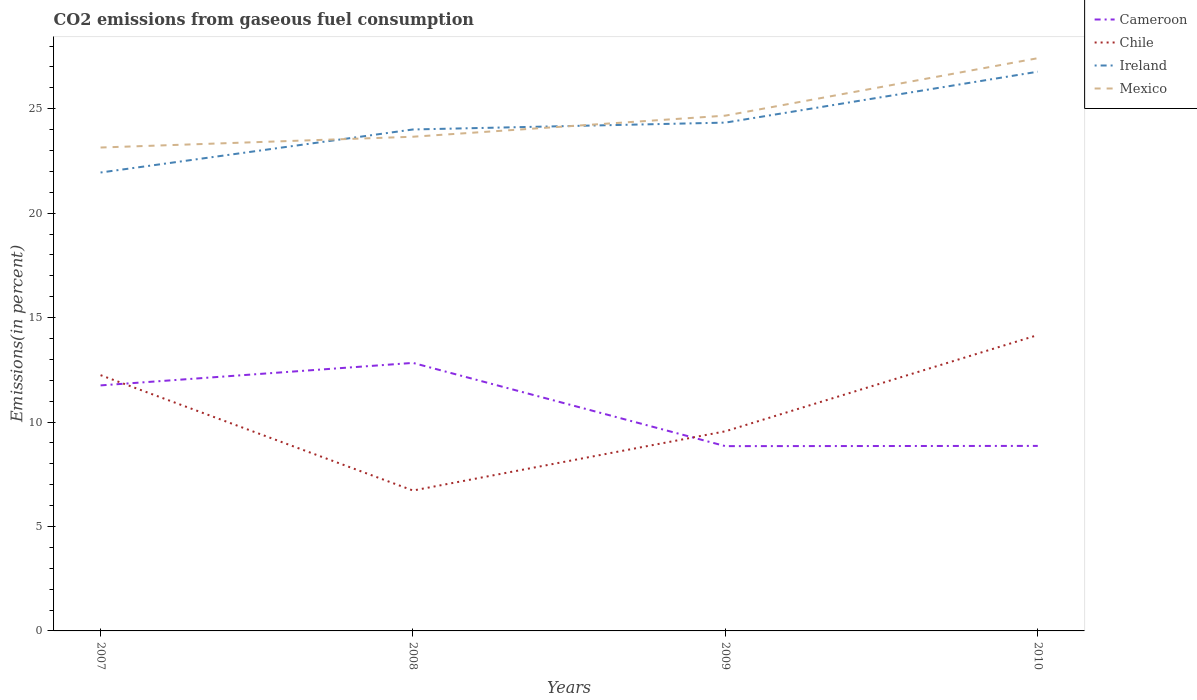How many different coloured lines are there?
Give a very brief answer. 4. Does the line corresponding to Ireland intersect with the line corresponding to Cameroon?
Provide a succinct answer. No. Is the number of lines equal to the number of legend labels?
Your response must be concise. Yes. Across all years, what is the maximum total CO2 emitted in Ireland?
Give a very brief answer. 21.95. What is the total total CO2 emitted in Ireland in the graph?
Your answer should be very brief. -4.83. What is the difference between the highest and the second highest total CO2 emitted in Chile?
Offer a terse response. 7.44. What is the difference between the highest and the lowest total CO2 emitted in Mexico?
Your answer should be very brief. 1. Is the total CO2 emitted in Chile strictly greater than the total CO2 emitted in Cameroon over the years?
Provide a short and direct response. No. How many years are there in the graph?
Provide a succinct answer. 4. Are the values on the major ticks of Y-axis written in scientific E-notation?
Ensure brevity in your answer.  No. Does the graph contain any zero values?
Ensure brevity in your answer.  No. How many legend labels are there?
Your answer should be very brief. 4. What is the title of the graph?
Give a very brief answer. CO2 emissions from gaseous fuel consumption. What is the label or title of the X-axis?
Give a very brief answer. Years. What is the label or title of the Y-axis?
Make the answer very short. Emissions(in percent). What is the Emissions(in percent) in Cameroon in 2007?
Provide a short and direct response. 11.75. What is the Emissions(in percent) in Chile in 2007?
Make the answer very short. 12.24. What is the Emissions(in percent) of Ireland in 2007?
Your response must be concise. 21.95. What is the Emissions(in percent) of Mexico in 2007?
Provide a succinct answer. 23.14. What is the Emissions(in percent) in Cameroon in 2008?
Make the answer very short. 12.83. What is the Emissions(in percent) in Chile in 2008?
Keep it short and to the point. 6.72. What is the Emissions(in percent) of Ireland in 2008?
Offer a terse response. 24.01. What is the Emissions(in percent) in Mexico in 2008?
Your answer should be compact. 23.66. What is the Emissions(in percent) of Cameroon in 2009?
Offer a very short reply. 8.85. What is the Emissions(in percent) in Chile in 2009?
Make the answer very short. 9.56. What is the Emissions(in percent) in Ireland in 2009?
Give a very brief answer. 24.33. What is the Emissions(in percent) in Mexico in 2009?
Provide a short and direct response. 24.67. What is the Emissions(in percent) of Cameroon in 2010?
Make the answer very short. 8.86. What is the Emissions(in percent) in Chile in 2010?
Offer a terse response. 14.16. What is the Emissions(in percent) of Ireland in 2010?
Your response must be concise. 26.77. What is the Emissions(in percent) of Mexico in 2010?
Keep it short and to the point. 27.42. Across all years, what is the maximum Emissions(in percent) of Cameroon?
Your response must be concise. 12.83. Across all years, what is the maximum Emissions(in percent) of Chile?
Provide a succinct answer. 14.16. Across all years, what is the maximum Emissions(in percent) of Ireland?
Keep it short and to the point. 26.77. Across all years, what is the maximum Emissions(in percent) of Mexico?
Give a very brief answer. 27.42. Across all years, what is the minimum Emissions(in percent) in Cameroon?
Your answer should be very brief. 8.85. Across all years, what is the minimum Emissions(in percent) of Chile?
Keep it short and to the point. 6.72. Across all years, what is the minimum Emissions(in percent) of Ireland?
Your answer should be very brief. 21.95. Across all years, what is the minimum Emissions(in percent) of Mexico?
Provide a succinct answer. 23.14. What is the total Emissions(in percent) of Cameroon in the graph?
Provide a succinct answer. 42.29. What is the total Emissions(in percent) of Chile in the graph?
Provide a short and direct response. 42.69. What is the total Emissions(in percent) in Ireland in the graph?
Your answer should be very brief. 97.06. What is the total Emissions(in percent) of Mexico in the graph?
Give a very brief answer. 98.88. What is the difference between the Emissions(in percent) in Cameroon in 2007 and that in 2008?
Give a very brief answer. -1.08. What is the difference between the Emissions(in percent) in Chile in 2007 and that in 2008?
Your response must be concise. 5.52. What is the difference between the Emissions(in percent) in Ireland in 2007 and that in 2008?
Keep it short and to the point. -2.06. What is the difference between the Emissions(in percent) in Mexico in 2007 and that in 2008?
Your answer should be compact. -0.52. What is the difference between the Emissions(in percent) in Cameroon in 2007 and that in 2009?
Provide a short and direct response. 2.91. What is the difference between the Emissions(in percent) in Chile in 2007 and that in 2009?
Provide a short and direct response. 2.69. What is the difference between the Emissions(in percent) of Ireland in 2007 and that in 2009?
Ensure brevity in your answer.  -2.39. What is the difference between the Emissions(in percent) in Mexico in 2007 and that in 2009?
Ensure brevity in your answer.  -1.53. What is the difference between the Emissions(in percent) in Cameroon in 2007 and that in 2010?
Your response must be concise. 2.9. What is the difference between the Emissions(in percent) in Chile in 2007 and that in 2010?
Ensure brevity in your answer.  -1.92. What is the difference between the Emissions(in percent) of Ireland in 2007 and that in 2010?
Give a very brief answer. -4.83. What is the difference between the Emissions(in percent) of Mexico in 2007 and that in 2010?
Offer a very short reply. -4.28. What is the difference between the Emissions(in percent) of Cameroon in 2008 and that in 2009?
Give a very brief answer. 3.98. What is the difference between the Emissions(in percent) in Chile in 2008 and that in 2009?
Your answer should be compact. -2.83. What is the difference between the Emissions(in percent) in Ireland in 2008 and that in 2009?
Make the answer very short. -0.33. What is the difference between the Emissions(in percent) of Mexico in 2008 and that in 2009?
Make the answer very short. -1.01. What is the difference between the Emissions(in percent) in Cameroon in 2008 and that in 2010?
Make the answer very short. 3.97. What is the difference between the Emissions(in percent) of Chile in 2008 and that in 2010?
Your response must be concise. -7.44. What is the difference between the Emissions(in percent) in Ireland in 2008 and that in 2010?
Provide a short and direct response. -2.77. What is the difference between the Emissions(in percent) in Mexico in 2008 and that in 2010?
Provide a short and direct response. -3.76. What is the difference between the Emissions(in percent) in Cameroon in 2009 and that in 2010?
Offer a terse response. -0.01. What is the difference between the Emissions(in percent) of Chile in 2009 and that in 2010?
Your answer should be compact. -4.61. What is the difference between the Emissions(in percent) in Ireland in 2009 and that in 2010?
Offer a very short reply. -2.44. What is the difference between the Emissions(in percent) of Mexico in 2009 and that in 2010?
Your answer should be very brief. -2.75. What is the difference between the Emissions(in percent) of Cameroon in 2007 and the Emissions(in percent) of Chile in 2008?
Your answer should be very brief. 5.03. What is the difference between the Emissions(in percent) of Cameroon in 2007 and the Emissions(in percent) of Ireland in 2008?
Offer a terse response. -12.25. What is the difference between the Emissions(in percent) of Cameroon in 2007 and the Emissions(in percent) of Mexico in 2008?
Make the answer very short. -11.9. What is the difference between the Emissions(in percent) in Chile in 2007 and the Emissions(in percent) in Ireland in 2008?
Give a very brief answer. -11.76. What is the difference between the Emissions(in percent) in Chile in 2007 and the Emissions(in percent) in Mexico in 2008?
Give a very brief answer. -11.41. What is the difference between the Emissions(in percent) of Ireland in 2007 and the Emissions(in percent) of Mexico in 2008?
Offer a very short reply. -1.71. What is the difference between the Emissions(in percent) in Cameroon in 2007 and the Emissions(in percent) in Chile in 2009?
Your response must be concise. 2.2. What is the difference between the Emissions(in percent) in Cameroon in 2007 and the Emissions(in percent) in Ireland in 2009?
Your answer should be very brief. -12.58. What is the difference between the Emissions(in percent) in Cameroon in 2007 and the Emissions(in percent) in Mexico in 2009?
Offer a terse response. -12.91. What is the difference between the Emissions(in percent) of Chile in 2007 and the Emissions(in percent) of Ireland in 2009?
Ensure brevity in your answer.  -12.09. What is the difference between the Emissions(in percent) in Chile in 2007 and the Emissions(in percent) in Mexico in 2009?
Your answer should be compact. -12.42. What is the difference between the Emissions(in percent) of Ireland in 2007 and the Emissions(in percent) of Mexico in 2009?
Offer a very short reply. -2.72. What is the difference between the Emissions(in percent) in Cameroon in 2007 and the Emissions(in percent) in Chile in 2010?
Provide a short and direct response. -2.41. What is the difference between the Emissions(in percent) of Cameroon in 2007 and the Emissions(in percent) of Ireland in 2010?
Offer a very short reply. -15.02. What is the difference between the Emissions(in percent) in Cameroon in 2007 and the Emissions(in percent) in Mexico in 2010?
Your answer should be very brief. -15.66. What is the difference between the Emissions(in percent) in Chile in 2007 and the Emissions(in percent) in Ireland in 2010?
Keep it short and to the point. -14.53. What is the difference between the Emissions(in percent) in Chile in 2007 and the Emissions(in percent) in Mexico in 2010?
Ensure brevity in your answer.  -15.17. What is the difference between the Emissions(in percent) of Ireland in 2007 and the Emissions(in percent) of Mexico in 2010?
Your answer should be very brief. -5.47. What is the difference between the Emissions(in percent) in Cameroon in 2008 and the Emissions(in percent) in Chile in 2009?
Give a very brief answer. 3.27. What is the difference between the Emissions(in percent) of Cameroon in 2008 and the Emissions(in percent) of Ireland in 2009?
Give a very brief answer. -11.5. What is the difference between the Emissions(in percent) in Cameroon in 2008 and the Emissions(in percent) in Mexico in 2009?
Your answer should be very brief. -11.84. What is the difference between the Emissions(in percent) in Chile in 2008 and the Emissions(in percent) in Ireland in 2009?
Provide a succinct answer. -17.61. What is the difference between the Emissions(in percent) of Chile in 2008 and the Emissions(in percent) of Mexico in 2009?
Your answer should be compact. -17.95. What is the difference between the Emissions(in percent) in Ireland in 2008 and the Emissions(in percent) in Mexico in 2009?
Provide a short and direct response. -0.66. What is the difference between the Emissions(in percent) of Cameroon in 2008 and the Emissions(in percent) of Chile in 2010?
Provide a short and direct response. -1.33. What is the difference between the Emissions(in percent) of Cameroon in 2008 and the Emissions(in percent) of Ireland in 2010?
Give a very brief answer. -13.94. What is the difference between the Emissions(in percent) of Cameroon in 2008 and the Emissions(in percent) of Mexico in 2010?
Provide a short and direct response. -14.59. What is the difference between the Emissions(in percent) of Chile in 2008 and the Emissions(in percent) of Ireland in 2010?
Provide a succinct answer. -20.05. What is the difference between the Emissions(in percent) of Chile in 2008 and the Emissions(in percent) of Mexico in 2010?
Your answer should be very brief. -20.7. What is the difference between the Emissions(in percent) of Ireland in 2008 and the Emissions(in percent) of Mexico in 2010?
Provide a short and direct response. -3.41. What is the difference between the Emissions(in percent) of Cameroon in 2009 and the Emissions(in percent) of Chile in 2010?
Provide a short and direct response. -5.32. What is the difference between the Emissions(in percent) of Cameroon in 2009 and the Emissions(in percent) of Ireland in 2010?
Make the answer very short. -17.92. What is the difference between the Emissions(in percent) of Cameroon in 2009 and the Emissions(in percent) of Mexico in 2010?
Ensure brevity in your answer.  -18.57. What is the difference between the Emissions(in percent) of Chile in 2009 and the Emissions(in percent) of Ireland in 2010?
Provide a succinct answer. -17.21. What is the difference between the Emissions(in percent) of Chile in 2009 and the Emissions(in percent) of Mexico in 2010?
Ensure brevity in your answer.  -17.86. What is the difference between the Emissions(in percent) of Ireland in 2009 and the Emissions(in percent) of Mexico in 2010?
Provide a succinct answer. -3.08. What is the average Emissions(in percent) of Cameroon per year?
Make the answer very short. 10.57. What is the average Emissions(in percent) of Chile per year?
Offer a very short reply. 10.67. What is the average Emissions(in percent) of Ireland per year?
Your answer should be compact. 24.26. What is the average Emissions(in percent) in Mexico per year?
Your answer should be very brief. 24.72. In the year 2007, what is the difference between the Emissions(in percent) of Cameroon and Emissions(in percent) of Chile?
Provide a short and direct response. -0.49. In the year 2007, what is the difference between the Emissions(in percent) of Cameroon and Emissions(in percent) of Ireland?
Your answer should be compact. -10.19. In the year 2007, what is the difference between the Emissions(in percent) in Cameroon and Emissions(in percent) in Mexico?
Your answer should be compact. -11.39. In the year 2007, what is the difference between the Emissions(in percent) in Chile and Emissions(in percent) in Ireland?
Give a very brief answer. -9.7. In the year 2007, what is the difference between the Emissions(in percent) in Chile and Emissions(in percent) in Mexico?
Your answer should be compact. -10.9. In the year 2007, what is the difference between the Emissions(in percent) in Ireland and Emissions(in percent) in Mexico?
Make the answer very short. -1.2. In the year 2008, what is the difference between the Emissions(in percent) of Cameroon and Emissions(in percent) of Chile?
Offer a terse response. 6.11. In the year 2008, what is the difference between the Emissions(in percent) of Cameroon and Emissions(in percent) of Ireland?
Ensure brevity in your answer.  -11.17. In the year 2008, what is the difference between the Emissions(in percent) of Cameroon and Emissions(in percent) of Mexico?
Provide a short and direct response. -10.83. In the year 2008, what is the difference between the Emissions(in percent) in Chile and Emissions(in percent) in Ireland?
Give a very brief answer. -17.28. In the year 2008, what is the difference between the Emissions(in percent) in Chile and Emissions(in percent) in Mexico?
Make the answer very short. -16.94. In the year 2008, what is the difference between the Emissions(in percent) in Ireland and Emissions(in percent) in Mexico?
Offer a very short reply. 0.35. In the year 2009, what is the difference between the Emissions(in percent) in Cameroon and Emissions(in percent) in Chile?
Ensure brevity in your answer.  -0.71. In the year 2009, what is the difference between the Emissions(in percent) in Cameroon and Emissions(in percent) in Ireland?
Your answer should be very brief. -15.49. In the year 2009, what is the difference between the Emissions(in percent) of Cameroon and Emissions(in percent) of Mexico?
Keep it short and to the point. -15.82. In the year 2009, what is the difference between the Emissions(in percent) of Chile and Emissions(in percent) of Ireland?
Ensure brevity in your answer.  -14.78. In the year 2009, what is the difference between the Emissions(in percent) of Chile and Emissions(in percent) of Mexico?
Provide a succinct answer. -15.11. In the year 2009, what is the difference between the Emissions(in percent) in Ireland and Emissions(in percent) in Mexico?
Your response must be concise. -0.33. In the year 2010, what is the difference between the Emissions(in percent) of Cameroon and Emissions(in percent) of Chile?
Offer a very short reply. -5.31. In the year 2010, what is the difference between the Emissions(in percent) of Cameroon and Emissions(in percent) of Ireland?
Provide a succinct answer. -17.91. In the year 2010, what is the difference between the Emissions(in percent) of Cameroon and Emissions(in percent) of Mexico?
Make the answer very short. -18.56. In the year 2010, what is the difference between the Emissions(in percent) in Chile and Emissions(in percent) in Ireland?
Provide a succinct answer. -12.61. In the year 2010, what is the difference between the Emissions(in percent) in Chile and Emissions(in percent) in Mexico?
Offer a terse response. -13.25. In the year 2010, what is the difference between the Emissions(in percent) in Ireland and Emissions(in percent) in Mexico?
Offer a terse response. -0.65. What is the ratio of the Emissions(in percent) of Cameroon in 2007 to that in 2008?
Keep it short and to the point. 0.92. What is the ratio of the Emissions(in percent) in Chile in 2007 to that in 2008?
Keep it short and to the point. 1.82. What is the ratio of the Emissions(in percent) of Ireland in 2007 to that in 2008?
Keep it short and to the point. 0.91. What is the ratio of the Emissions(in percent) in Mexico in 2007 to that in 2008?
Offer a very short reply. 0.98. What is the ratio of the Emissions(in percent) of Cameroon in 2007 to that in 2009?
Your answer should be very brief. 1.33. What is the ratio of the Emissions(in percent) of Chile in 2007 to that in 2009?
Your response must be concise. 1.28. What is the ratio of the Emissions(in percent) in Ireland in 2007 to that in 2009?
Provide a succinct answer. 0.9. What is the ratio of the Emissions(in percent) in Mexico in 2007 to that in 2009?
Ensure brevity in your answer.  0.94. What is the ratio of the Emissions(in percent) of Cameroon in 2007 to that in 2010?
Ensure brevity in your answer.  1.33. What is the ratio of the Emissions(in percent) in Chile in 2007 to that in 2010?
Provide a succinct answer. 0.86. What is the ratio of the Emissions(in percent) in Ireland in 2007 to that in 2010?
Offer a terse response. 0.82. What is the ratio of the Emissions(in percent) of Mexico in 2007 to that in 2010?
Give a very brief answer. 0.84. What is the ratio of the Emissions(in percent) in Cameroon in 2008 to that in 2009?
Provide a succinct answer. 1.45. What is the ratio of the Emissions(in percent) of Chile in 2008 to that in 2009?
Offer a very short reply. 0.7. What is the ratio of the Emissions(in percent) of Ireland in 2008 to that in 2009?
Offer a very short reply. 0.99. What is the ratio of the Emissions(in percent) in Mexico in 2008 to that in 2009?
Keep it short and to the point. 0.96. What is the ratio of the Emissions(in percent) in Cameroon in 2008 to that in 2010?
Keep it short and to the point. 1.45. What is the ratio of the Emissions(in percent) in Chile in 2008 to that in 2010?
Give a very brief answer. 0.47. What is the ratio of the Emissions(in percent) of Ireland in 2008 to that in 2010?
Your answer should be compact. 0.9. What is the ratio of the Emissions(in percent) of Mexico in 2008 to that in 2010?
Your response must be concise. 0.86. What is the ratio of the Emissions(in percent) of Chile in 2009 to that in 2010?
Your answer should be very brief. 0.67. What is the ratio of the Emissions(in percent) in Ireland in 2009 to that in 2010?
Keep it short and to the point. 0.91. What is the ratio of the Emissions(in percent) of Mexico in 2009 to that in 2010?
Your answer should be very brief. 0.9. What is the difference between the highest and the second highest Emissions(in percent) of Cameroon?
Keep it short and to the point. 1.08. What is the difference between the highest and the second highest Emissions(in percent) in Chile?
Provide a short and direct response. 1.92. What is the difference between the highest and the second highest Emissions(in percent) of Ireland?
Your answer should be very brief. 2.44. What is the difference between the highest and the second highest Emissions(in percent) of Mexico?
Provide a short and direct response. 2.75. What is the difference between the highest and the lowest Emissions(in percent) of Cameroon?
Your response must be concise. 3.98. What is the difference between the highest and the lowest Emissions(in percent) of Chile?
Provide a short and direct response. 7.44. What is the difference between the highest and the lowest Emissions(in percent) of Ireland?
Your response must be concise. 4.83. What is the difference between the highest and the lowest Emissions(in percent) of Mexico?
Provide a short and direct response. 4.28. 